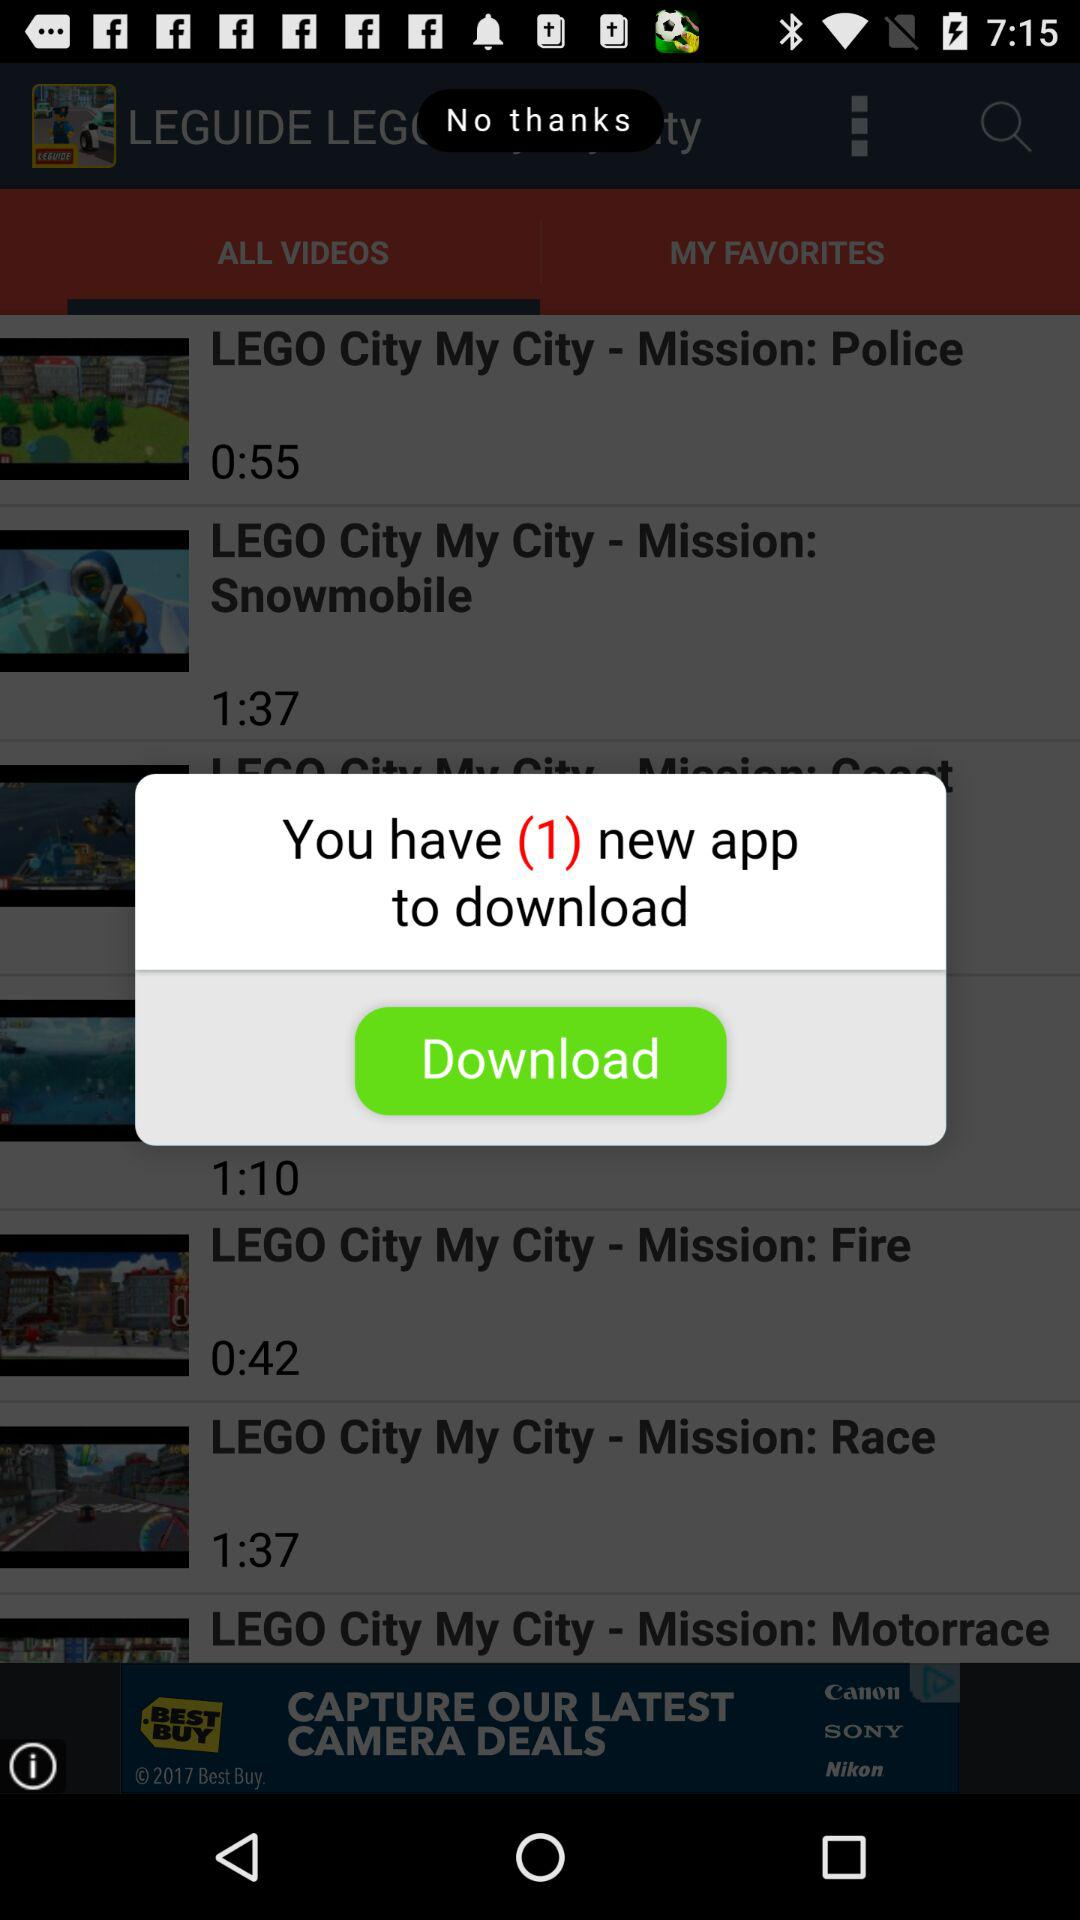How many applications are there to download? There is 1 application to download. 